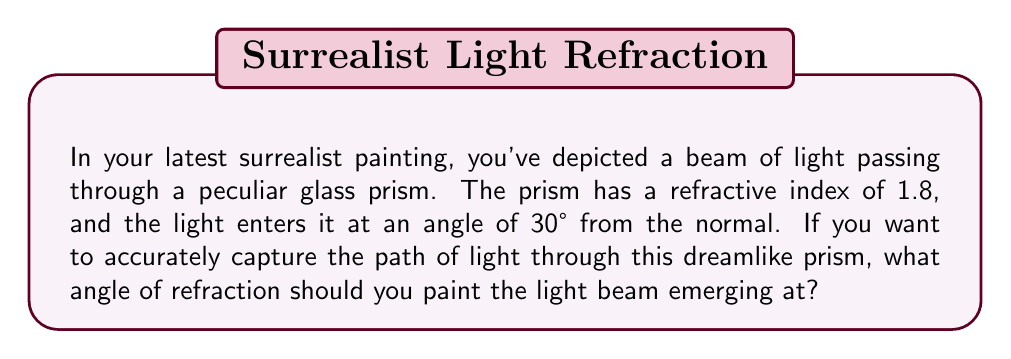Solve this math problem. To solve this problem, we'll use Snell's Law, which describes the relationship between the angles of incidence and refraction for light passing through different media. The formula is:

$$n_1 \sin(\theta_1) = n_2 \sin(\theta_2)$$

Where:
$n_1$ is the refractive index of the first medium (air in this case, which is approximately 1)
$n_2$ is the refractive index of the second medium (the glass prism, given as 1.8)
$\theta_1$ is the angle of incidence (given as 30°)
$\theta_2$ is the angle of refraction (what we're solving for)

Let's plug in the values we know:

$$1 \cdot \sin(30°) = 1.8 \cdot \sin(\theta_2)$$

Now, let's solve for $\theta_2$:

1. First, calculate $\sin(30°)$:
   $$\sin(30°) = 0.5$$

2. Substitute this value:
   $$0.5 = 1.8 \cdot \sin(\theta_2)$$

3. Divide both sides by 1.8:
   $$\frac{0.5}{1.8} = \sin(\theta_2)$$

4. Calculate this value:
   $$0.2778 = \sin(\theta_2)$$

5. To find $\theta_2$, we need to take the inverse sine (arcsin) of both sides:
   $$\theta_2 = \arcsin(0.2778)$$

6. Calculate this value:
   $$\theta_2 \approx 16.1°$$

Therefore, the angle of refraction is approximately 16.1°.
Answer: $16.1°$ 